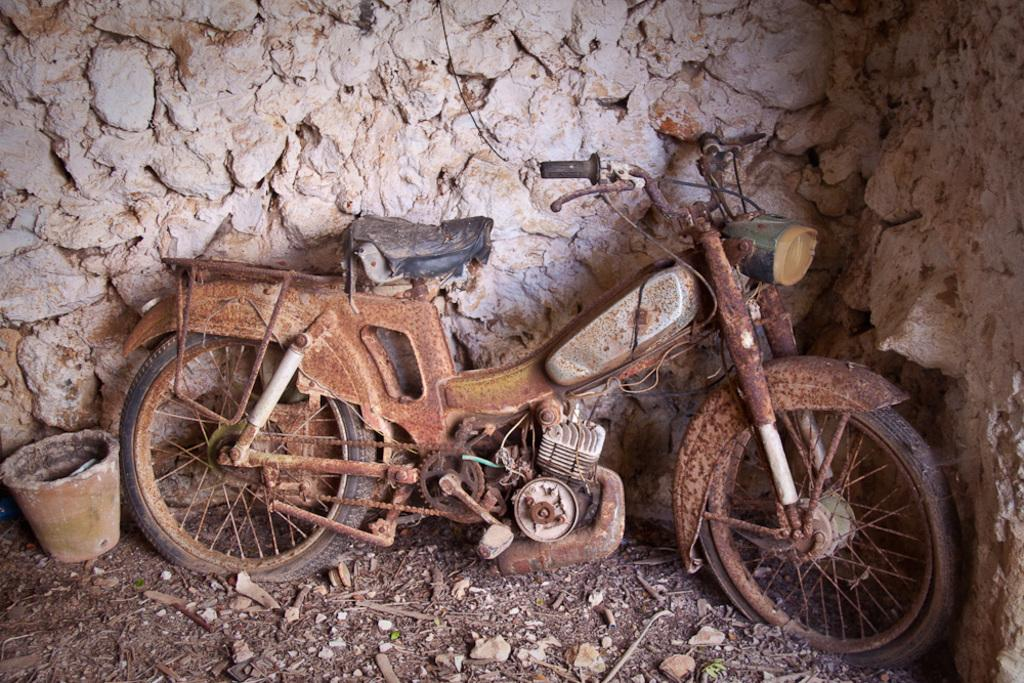What type of vehicle is in the image? There is a vehicle in the image, but the specific type is not mentioned. What other object can be seen on the land in the image? There is a pot on the land in the image. What structure is visible behind the vehicle in the image? There is a wall visible behind the vehicle in the image. What route is the clam taking in the image? There is no clam present in the image, so it is not possible to determine the route it might be taking. 